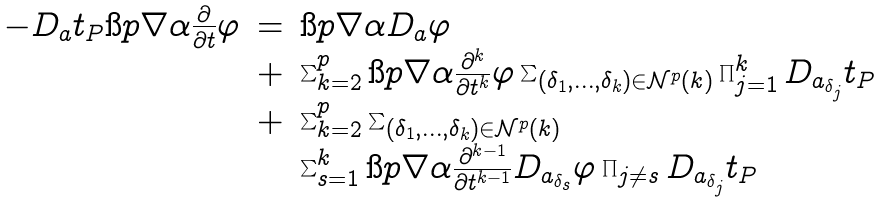Convert formula to latex. <formula><loc_0><loc_0><loc_500><loc_500>\begin{array} { r c l } - D _ { a } t _ { P } \i p { \nabla \alpha } { \frac { \partial } { \partial t } \varphi } & = & \i p { \nabla \alpha } { D _ { a } \varphi } \\ & + & \sum _ { k = 2 } ^ { p } \i p { \nabla \alpha } { \frac { \partial ^ { k } } { \partial t ^ { k } } \varphi } \sum _ { ( \delta _ { 1 } , \dots , \delta _ { k } ) \in \mathcal { N } ^ { p } ( k ) } \prod _ { j = 1 } ^ { k } D _ { a _ { \delta _ { j } } } t _ { P } \\ & + & \sum _ { k = 2 } ^ { p } \sum _ { ( \delta _ { 1 } , \dots , \delta _ { k } ) \in \mathcal { N } ^ { p } ( k ) } \\ & & \sum _ { s = 1 } ^ { k } \i p { \nabla \alpha } { \frac { \partial ^ { k - 1 } } { \partial t ^ { k - 1 } } D _ { a _ { \delta _ { s } } } \varphi } \prod _ { j \neq s } D _ { a _ { \delta _ { j } } } t _ { P } \end{array}</formula> 